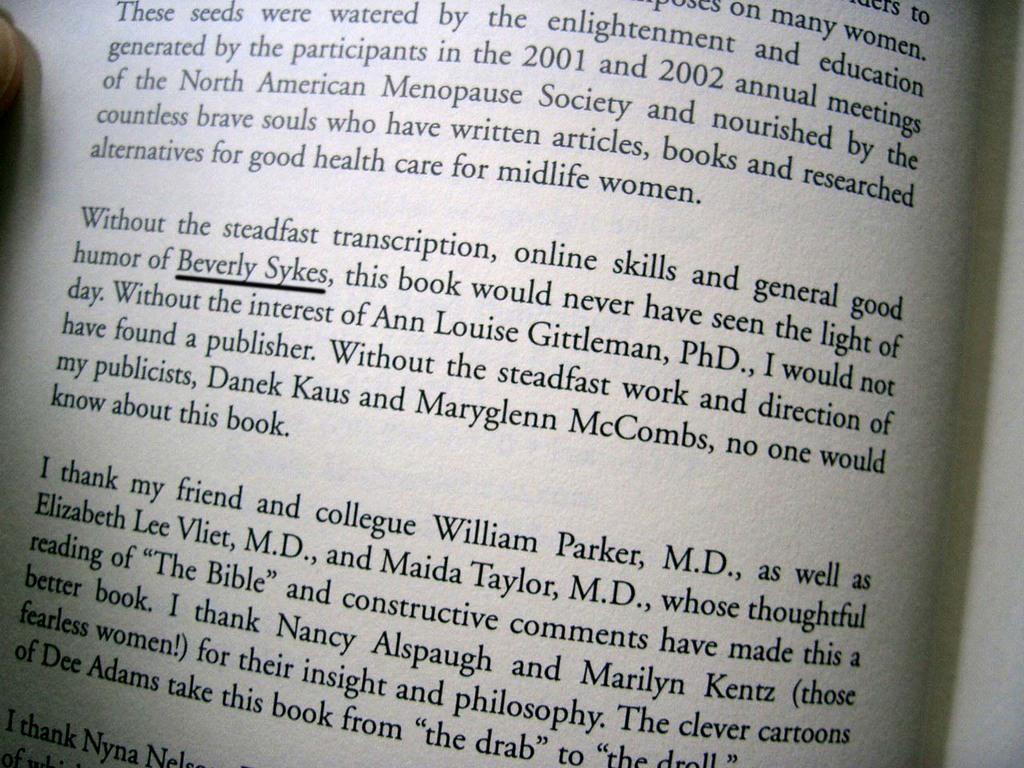What name is being displayed in the bottom paragraph?
Offer a very short reply. Beverly sykes. 